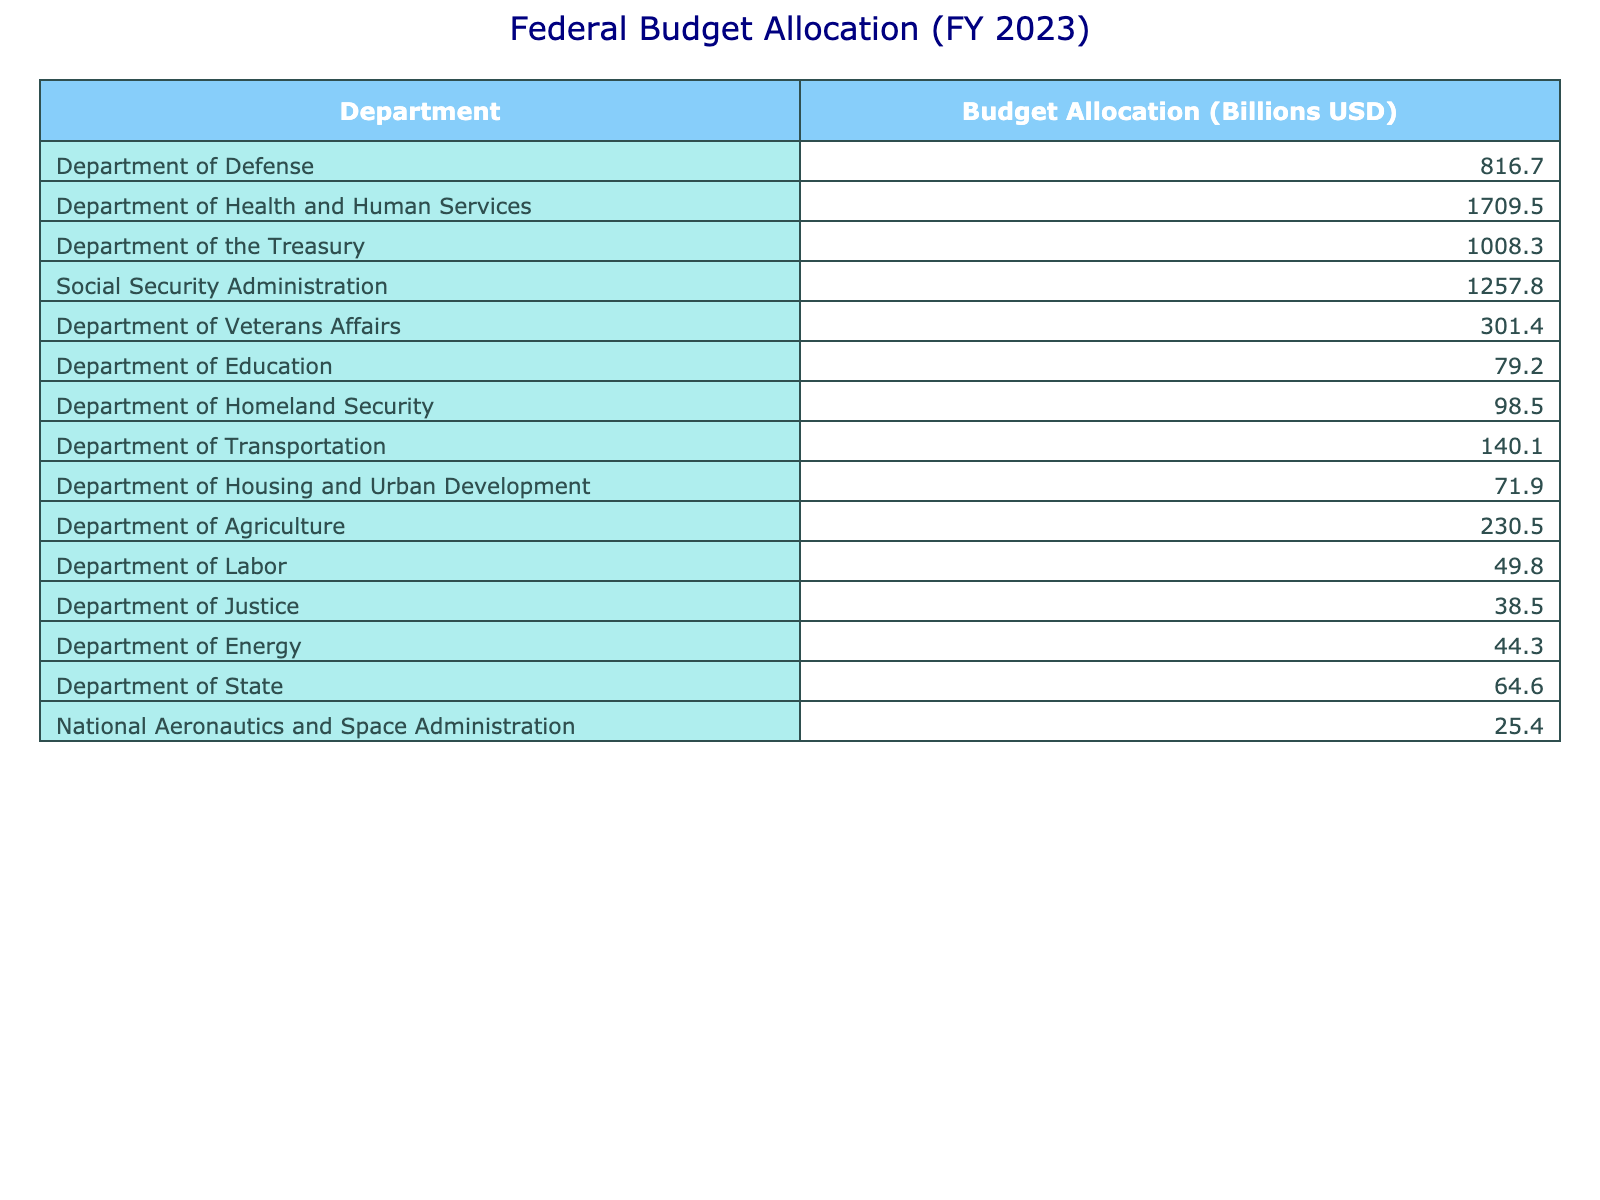What is the total budget allocated to the Department of Health and Human Services? The table shows that the budget allocated to the Department of Health and Human Services is 1709.5 billion USD.
Answer: 1709.5 billion USD Which department has the lowest budget allocation? The Department of Justice has the lowest budget allocation of 38.5 billion USD according to the table.
Answer: Department of Justice What is the combined budget of the Department of Defense and the Department of Veterans Affairs? The budget for the Department of Defense is 816.7 billion USD and for the Department of Veterans Affairs is 301.4 billion USD. Adding them gives 816.7 + 301.4 = 1118.1 billion USD.
Answer: 1118.1 billion USD Is the budget for the Department of Transportation greater than that of the Department of Homeland Security? The budget for the Department of Transportation is 140.1 billion USD, while the budget for the Department of Homeland Security is 98.5 billion USD, which indicates that it is greater.
Answer: Yes What is the average budget allocation across all departments listed in the table? First, sum the budget allocations: 816.7 + 1709.5 + 1008.3 + 1257.8 + 301.4 + 79.2 + 98.5 + 140.1 + 71.9 + 230.5 + 49.8 + 38.5 + 44.3 + 64.6 + 25.4 = 4671.8 billion USD. There are 14 departments, so the average is 4671.8 / 14 = 333.7 billion USD.
Answer: 333.7 billion USD What is the difference in budget allocation between the Department of Treasury and the Social Security Administration? The Department of Treasury has a budget of 1008.3 billion USD and the Social Security Administration has a budget of 1257.8 billion USD. The difference is calculated as 1257.8 - 1008.3 = 249.5 billion USD.
Answer: 249.5 billion USD Which department receives more than 500 billion USD in budget allocation? The table indicates that the Department of Defense (816.7 billion USD), Department of Health and Human Services (1709.5 billion USD), Department of the Treasury (1008.3 billion USD), and the Social Security Administration (1257.8 billion USD) all receive more than 500 billion USD in budget allocation.
Answer: Department of Defense, Department of Health and Human Services, Department of the Treasury, Social Security Administration What is the total budget allocation for the Departments of Education, Labor, and Energy combined? The budgets are 79.2 billion USD for Education, 49.8 billion USD for Labor, and 44.3 billion USD for Energy. Adding these gives 79.2 + 49.8 + 44.3 = 173.3 billion USD.
Answer: 173.3 billion USD Are the budget allocations for the National Aeronautics and Space Administration and the Department of State equal? The National Aeronautics and Space Administration has a budget of 25.4 billion USD, and the Department of State has a budget of 64.6 billion USD. Since 25.4 is not equal to 64.6, they are not equal.
Answer: No What is the total budget allocation for the Departments of Agriculture and Housing and Urban Development? The budget for Agriculture is 230.5 billion USD and for Housing and Urban Development is 71.9 billion USD. Their sum is 230.5 + 71.9 = 302.4 billion USD.
Answer: 302.4 billion USD Which two departments have a combined budget allocation that is less than 100 billion USD? The Department of Justice (38.5 billion USD) and the Department of Labor (49.8 billion USD) together have a combined budget of 38.5 + 49.8 = 88.3 billion USD, which is less than 100 billion USD.
Answer: Department of Justice and Department of Labor 